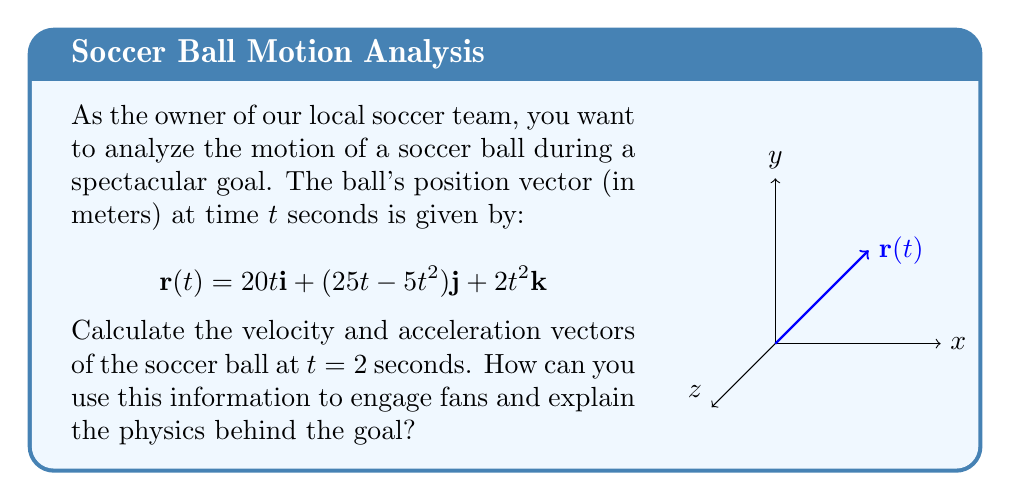Provide a solution to this math problem. Let's approach this step-by-step:

1) The velocity vector is the first derivative of the position vector:
   $$\mathbf{v}(t) = \frac{d\mathbf{r}}{dt} = 20\mathbf{i} + (25 - 10t)\mathbf{j} + 4t\mathbf{k}$$

2) The acceleration vector is the second derivative of the position vector or the first derivative of the velocity vector:
   $$\mathbf{a}(t) = \frac{d\mathbf{v}}{dt} = -10\mathbf{j} + 4\mathbf{k}$$

3) To find the velocity at t = 2 seconds, we substitute t = 2 into the velocity equation:
   $$\mathbf{v}(2) = 20\mathbf{i} + (25 - 10(2))\mathbf{j} + 4(2)\mathbf{k} = 20\mathbf{i} + 5\mathbf{j} + 8\mathbf{k}$$

4) The acceleration is constant and doesn't depend on t, so at t = 2 seconds:
   $$\mathbf{a}(2) = -10\mathbf{j} + 4\mathbf{k}$$

5) To interpret these results:
   - The velocity shows the ball is moving 20 m/s in the x-direction, 5 m/s in the y-direction, and 8 m/s in the z-direction at t = 2s.
   - The acceleration shows the ball is constantly decelerating at 10 m/s² in the y-direction (due to gravity) and accelerating at 4 m/s² in the z-direction.

This analysis can engage fans by demonstrating the physics behind the goal, showing how the ball's trajectory is affected by initial velocity and gravity, and potentially explaining factors like spin or air resistance that could further influence the ball's path.
Answer: $\mathbf{v}(2) = 20\mathbf{i} + 5\mathbf{j} + 8\mathbf{k}$, $\mathbf{a}(2) = -10\mathbf{j} + 4\mathbf{k}$ 